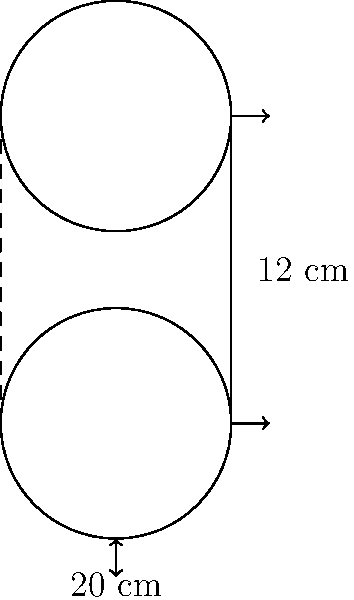As a guitar teacher, you're considering purchasing a new cylindrical amplifier for your lessons. The amplifier has a diameter of 20 cm and a height of 12 cm. Calculate the total surface area of the amplifier, including the top, bottom, and curved side. Round your answer to the nearest square centimeter. To calculate the total surface area of the cylindrical amplifier, we need to find the area of the circular top and bottom, as well as the area of the curved side. Let's break it down step-by-step:

1. Calculate the radius:
   Diameter = 20 cm, so radius = 20 cm ÷ 2 = 10 cm

2. Calculate the area of the circular top and bottom:
   Area of a circle = $\pi r^2$
   Area of one circular face = $\pi (10 \text{ cm})^2 = 100\pi \text{ cm}^2$
   Total area of top and bottom = $2 \times 100\pi \text{ cm}^2 = 200\pi \text{ cm}^2$

3. Calculate the area of the curved side:
   Area of curved side = Circumference × Height
   Circumference = $2\pi r = 2\pi(10 \text{ cm}) = 20\pi \text{ cm}$
   Area of curved side = $20\pi \text{ cm} \times 12 \text{ cm} = 240\pi \text{ cm}^2$

4. Calculate the total surface area:
   Total surface area = Area of top and bottom + Area of curved side
   Total surface area = $200\pi \text{ cm}^2 + 240\pi \text{ cm}^2 = 440\pi \text{ cm}^2$

5. Convert to a numerical value and round to the nearest square centimeter:
   $440\pi \text{ cm}^2 \approx 1,382.30 \text{ cm}^2$
   Rounded to the nearest square centimeter: 1,382 cm²
Answer: 1,382 cm² 